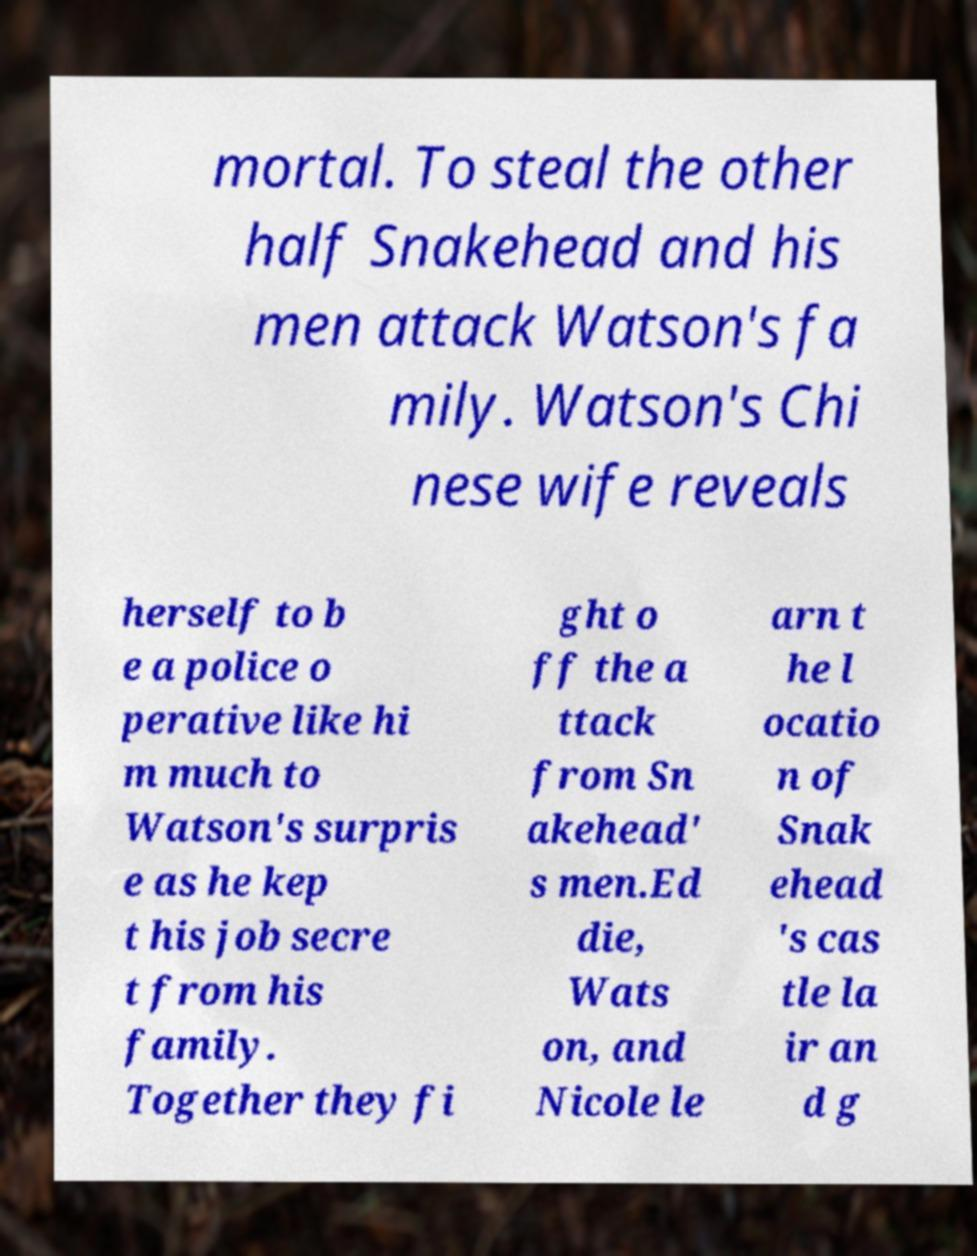There's text embedded in this image that I need extracted. Can you transcribe it verbatim? mortal. To steal the other half Snakehead and his men attack Watson's fa mily. Watson's Chi nese wife reveals herself to b e a police o perative like hi m much to Watson's surpris e as he kep t his job secre t from his family. Together they fi ght o ff the a ttack from Sn akehead' s men.Ed die, Wats on, and Nicole le arn t he l ocatio n of Snak ehead 's cas tle la ir an d g 